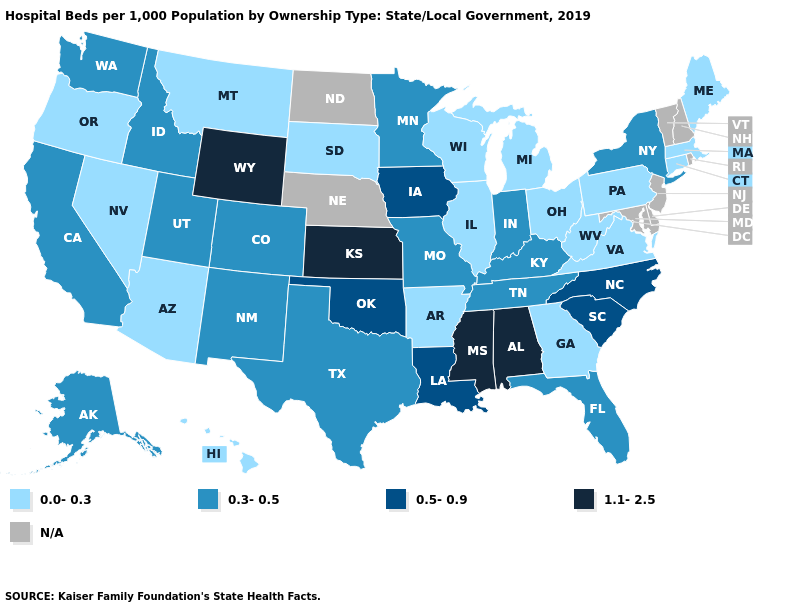Does Indiana have the lowest value in the USA?
Concise answer only. No. Name the states that have a value in the range 1.1-2.5?
Keep it brief. Alabama, Kansas, Mississippi, Wyoming. Is the legend a continuous bar?
Give a very brief answer. No. Does the map have missing data?
Be succinct. Yes. Does the map have missing data?
Be succinct. Yes. Which states have the lowest value in the USA?
Quick response, please. Arizona, Arkansas, Connecticut, Georgia, Hawaii, Illinois, Maine, Massachusetts, Michigan, Montana, Nevada, Ohio, Oregon, Pennsylvania, South Dakota, Virginia, West Virginia, Wisconsin. What is the lowest value in the USA?
Write a very short answer. 0.0-0.3. Name the states that have a value in the range 0.3-0.5?
Give a very brief answer. Alaska, California, Colorado, Florida, Idaho, Indiana, Kentucky, Minnesota, Missouri, New Mexico, New York, Tennessee, Texas, Utah, Washington. What is the value of Mississippi?
Give a very brief answer. 1.1-2.5. What is the value of Nebraska?
Give a very brief answer. N/A. What is the value of Washington?
Give a very brief answer. 0.3-0.5. What is the value of Alaska?
Concise answer only. 0.3-0.5. What is the value of Minnesota?
Concise answer only. 0.3-0.5. Among the states that border Illinois , which have the highest value?
Quick response, please. Iowa. 